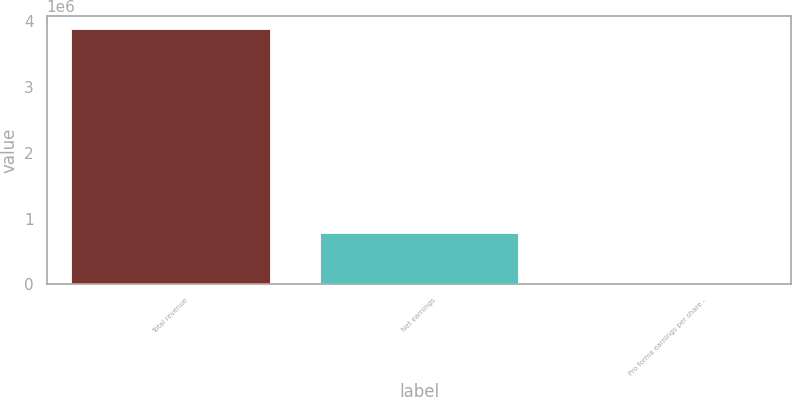<chart> <loc_0><loc_0><loc_500><loc_500><bar_chart><fcel>Total revenue<fcel>Net earnings<fcel>Pro forma earnings per share -<nl><fcel>3.88323e+06<fcel>776646<fcel>1.3<nl></chart> 